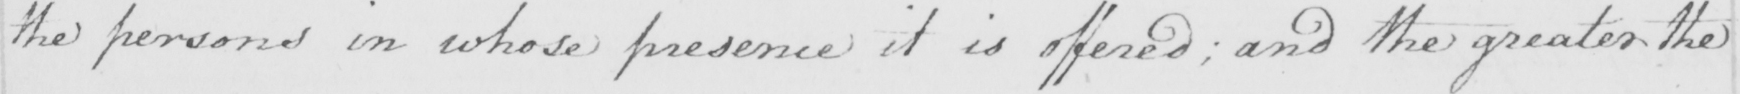Transcribe the text shown in this historical manuscript line. the persons in whose presence it is offered ; and the greater the 